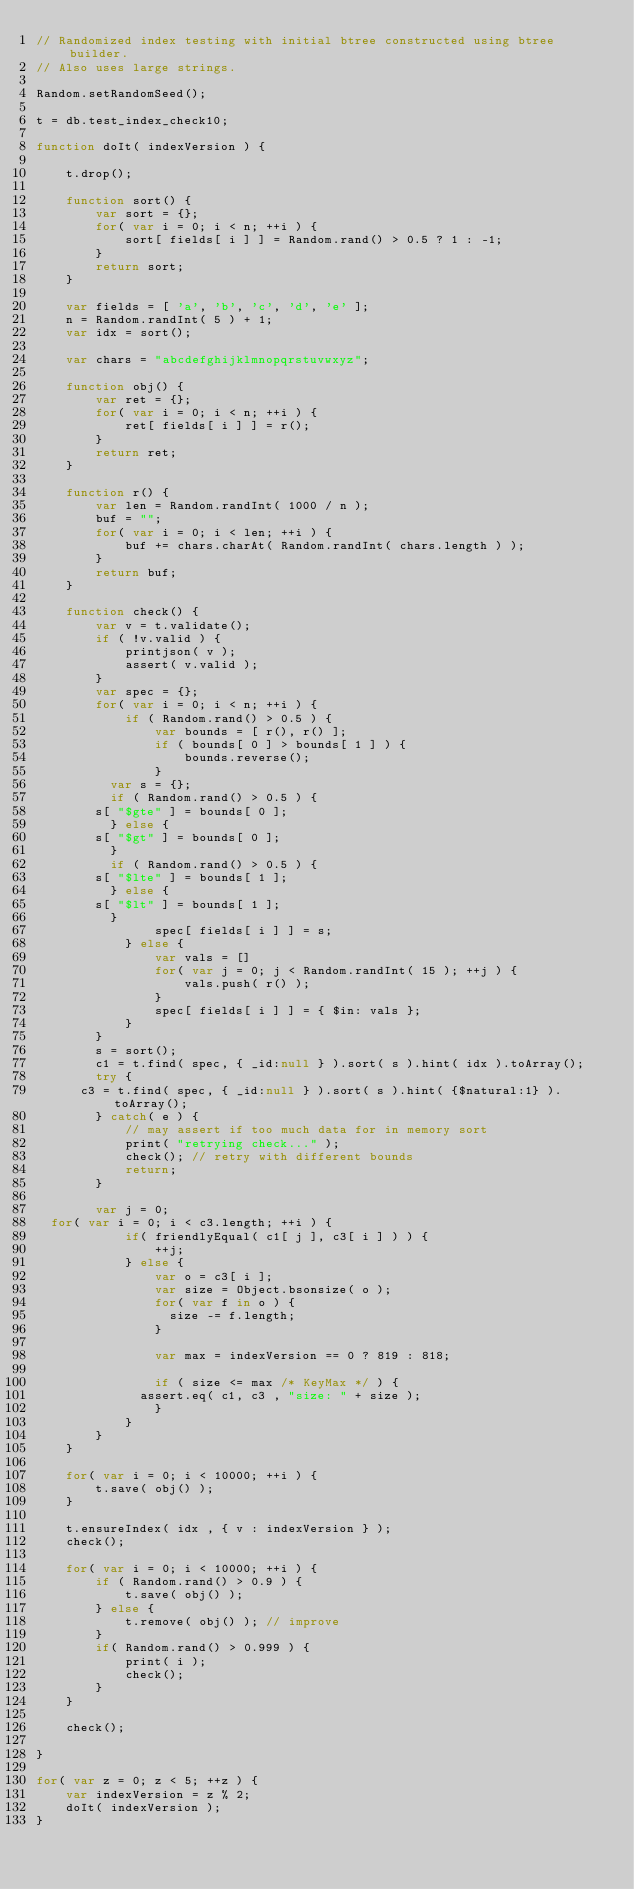<code> <loc_0><loc_0><loc_500><loc_500><_JavaScript_>// Randomized index testing with initial btree constructed using btree builder.
// Also uses large strings.

Random.setRandomSeed();

t = db.test_index_check10;

function doIt( indexVersion ) {

    t.drop();

    function sort() {
        var sort = {};
        for( var i = 0; i < n; ++i ) {
            sort[ fields[ i ] ] = Random.rand() > 0.5 ? 1 : -1;
        }    
        return sort;
    }

    var fields = [ 'a', 'b', 'c', 'd', 'e' ];
    n = Random.randInt( 5 ) + 1;
    var idx = sort();

    var chars = "abcdefghijklmnopqrstuvwxyz";
    
    function obj() {
        var ret = {};
        for( var i = 0; i < n; ++i ) {
            ret[ fields[ i ] ] = r();
        }
        return ret;
    }

    function r() {
        var len = Random.randInt( 1000 / n );
        buf = "";
        for( var i = 0; i < len; ++i ) {
            buf += chars.charAt( Random.randInt( chars.length ) );
        }
        return buf;
    }

    function check() {
        var v = t.validate();
        if ( !v.valid ) {
            printjson( v );
            assert( v.valid );
        }
        var spec = {};
        for( var i = 0; i < n; ++i ) {
            if ( Random.rand() > 0.5 ) {
                var bounds = [ r(), r() ];
                if ( bounds[ 0 ] > bounds[ 1 ] ) {
                    bounds.reverse();
                }
	        var s = {};
	        if ( Random.rand() > 0.5 ) {
		    s[ "$gte" ] = bounds[ 0 ];
	        } else {
		    s[ "$gt" ] = bounds[ 0 ];
	        }
	        if ( Random.rand() > 0.5 ) {
		    s[ "$lte" ] = bounds[ 1 ];
	        } else {
		    s[ "$lt" ] = bounds[ 1 ];
	        }
                spec[ fields[ i ] ] = s;
            } else {
                var vals = []
                for( var j = 0; j < Random.randInt( 15 ); ++j ) {
                    vals.push( r() );
                }
                spec[ fields[ i ] ] = { $in: vals };
            }
        }
        s = sort();
        c1 = t.find( spec, { _id:null } ).sort( s ).hint( idx ).toArray();
        try {
	    c3 = t.find( spec, { _id:null } ).sort( s ).hint( {$natural:1} ).toArray();
        } catch( e ) {
            // may assert if too much data for in memory sort
            print( "retrying check..." );
            check(); // retry with different bounds
            return;
        }

        var j = 0;
	for( var i = 0; i < c3.length; ++i ) {
            if( friendlyEqual( c1[ j ], c3[ i ] ) ) {
                ++j;
            } else {
                var o = c3[ i ];
                var size = Object.bsonsize( o );
                for( var f in o ) {
             	    size -= f.length;
                }
                
                var max = indexVersion == 0 ? 819 : 818;
                
                if ( size <= max /* KeyMax */ ) {
	            assert.eq( c1, c3 , "size: " + size );
                }
            }
        }
    }

    for( var i = 0; i < 10000; ++i ) {
        t.save( obj() );
    }
    
    t.ensureIndex( idx , { v : indexVersion } );
    check();

    for( var i = 0; i < 10000; ++i ) {
        if ( Random.rand() > 0.9 ) {
            t.save( obj() );
        } else {
            t.remove( obj() ); // improve
        }
        if( Random.rand() > 0.999 ) {
            print( i );
            check();
        }
    }

    check();

}

for( var z = 0; z < 5; ++z ) {
    var indexVersion = z % 2;
    doIt( indexVersion );
}
</code> 